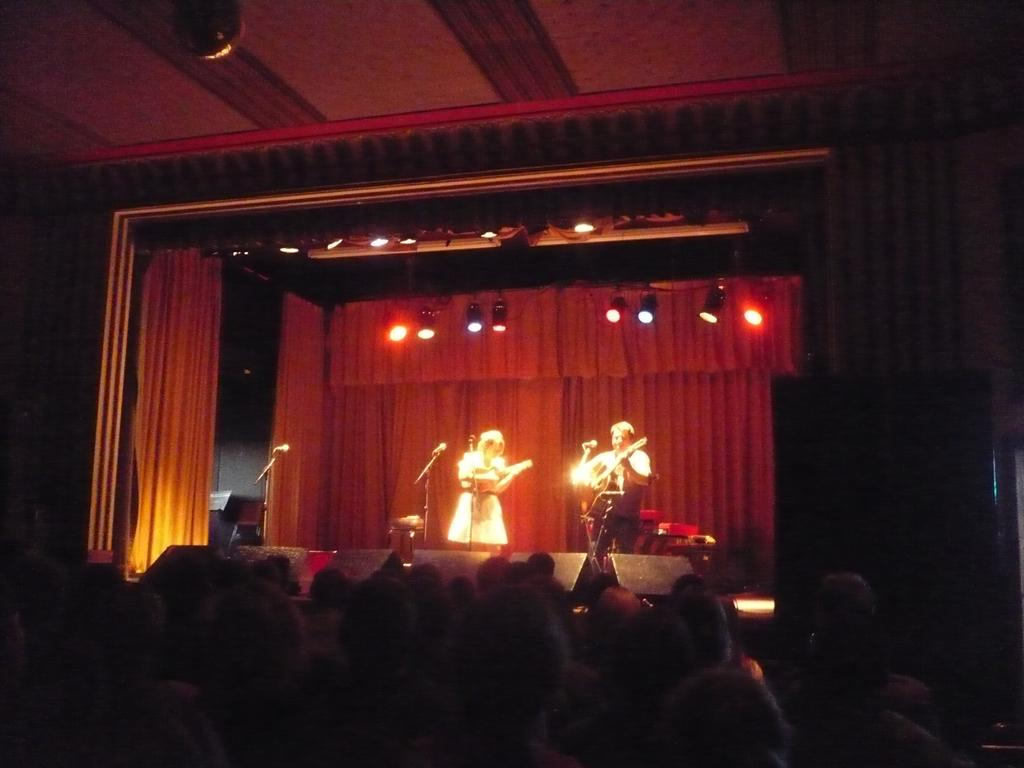How many people are in the image? There are people in the image, specifically a man and a woman. What are the man and woman doing in the image? The man and woman are playing a musical instrument in the image. What can be seen at the top of the image? There are lights visible at the top of the image. How many oranges are being used as percussion instruments in the image? There are no oranges present in the image, and they are not being used as percussion instruments. 